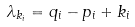<formula> <loc_0><loc_0><loc_500><loc_500>\lambda _ { k _ { i } } = q _ { i } - p _ { i } + k _ { i }</formula> 